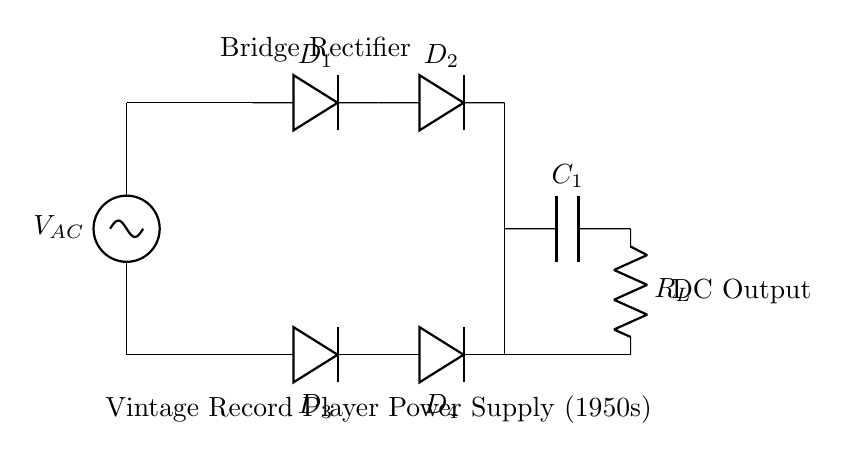What type of circuit is depicted? The circuit shown is a bridge rectifier, which is identified by the arrangement of four diodes connected in a bridge configuration.
Answer: bridge rectifier How many diodes are in the circuit? The circuit contains four diodes, labeled D1, D2, D3, and D4, as shown in the bridge configuration.
Answer: four What is the role of capacitor C1 in the circuit? Capacitor C1 is used for smoothing the output voltage, reducing the ripple voltage in the DC output and providing a steadier current to the load.
Answer: smoothing What does R_L represent in the circuit? R_L represents the load resistor in the circuit, which consumes electric power and is connected to the output of the rectifier.
Answer: load resistor How is AC voltage input connected in this circuit? The AC voltage source is connected between the upper leads of the bridge rectify at the two diodes D1 and D2, allowing current flow through the diodes.
Answer: connected at the top What can be inferred about the direction of current flow in this rectifier circuit? The current can flow in either direction during positive or negative cycles of the AC input, as both polarities are handled by the diodes in the bridge configuration.
Answer: bidirectional What does the label "Vintage Record Player Power Supply (1950s)" indicate? The label indicates the application for which this bridge rectifier circuit is designed, pointing to its historical context and its use in power supplies during that time.
Answer: application context 